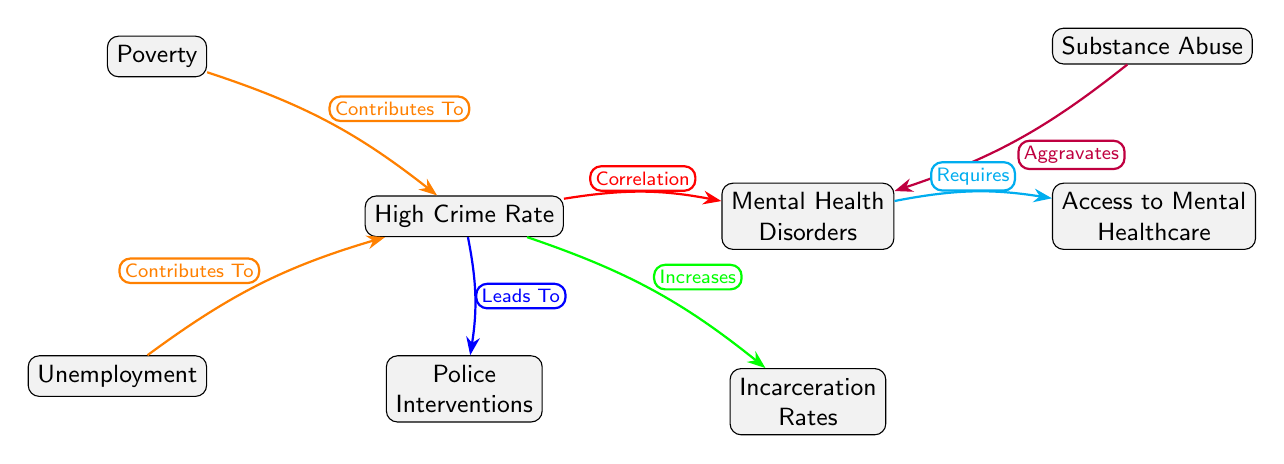What is the main correlation illustrated in the diagram? The diagram shows a correlation between "High Crime Rate" and "Mental Health Disorders." The connection is indicated by the red edge labeled as "Correlation."
Answer: Correlation Which two factors contribute to high crime rates? Both "Poverty" and "Unemployment" are labeled as factors that "Contribute To" high crime rates, as indicated by the orange edges connecting these nodes to "High Crime Rate."
Answer: Poverty, Unemployment What does "Substance Abuse" do in relation to "Mental Health Disorders"? The diagram indicates that "Substance Abuse" "Aggravates" "Mental Health Disorders," as shown by the purple edge between these two nodes.
Answer: Aggravates How does "High Crime Rate" affect "Incarceration Rates"? The diagram illustrates that "High Crime Rate" "Increases" "Incarceration Rates," highlighted by the green edge connecting these nodes.
Answer: Increases What is required for "Mental Health Disorders" according to the diagram? "Access to Mental Healthcare" is labeled as a requirement for "Mental Health Disorders," indicated by the cyan edge linking these nodes.
Answer: Requires What is the total number of nodes present in the diagram? The diagram contains a total of 7 nodes, including "High Crime Rate," "Mental Health Disorders," "Poverty," "Unemployment," "Substance Abuse," "Police Interventions," and "Incarceration Rates."
Answer: 7 How many edges connect to "High Crime Rate"? There are three edges connecting to "High Crime Rate": one from "Poverty," one from "Unemployment," and one leading to "Police Interventions."
Answer: 3 Which two nodes are related to access to healthcare? The diagram shows that "Access to Mental Healthcare" is required by "Mental Health Disorders." This is the only healthcare-related node in the diagram.
Answer: Mental Health Disorders What is the relationship between "High Crime Rate" and "Police Interventions"? The diagram specifies that "High Crime Rate" "Leads To" "Police Interventions," as denoted by the blue edge connecting these two nodes.
Answer: Leads To 